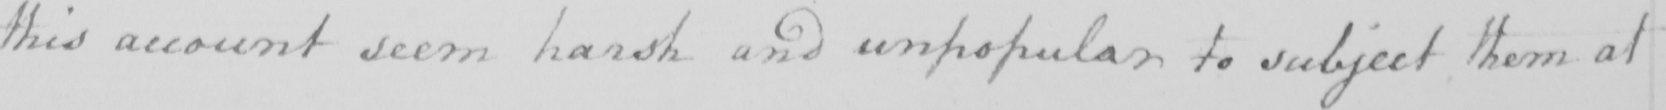Transcribe the text shown in this historical manuscript line. this account seem harsh and unpopular to subject them at 